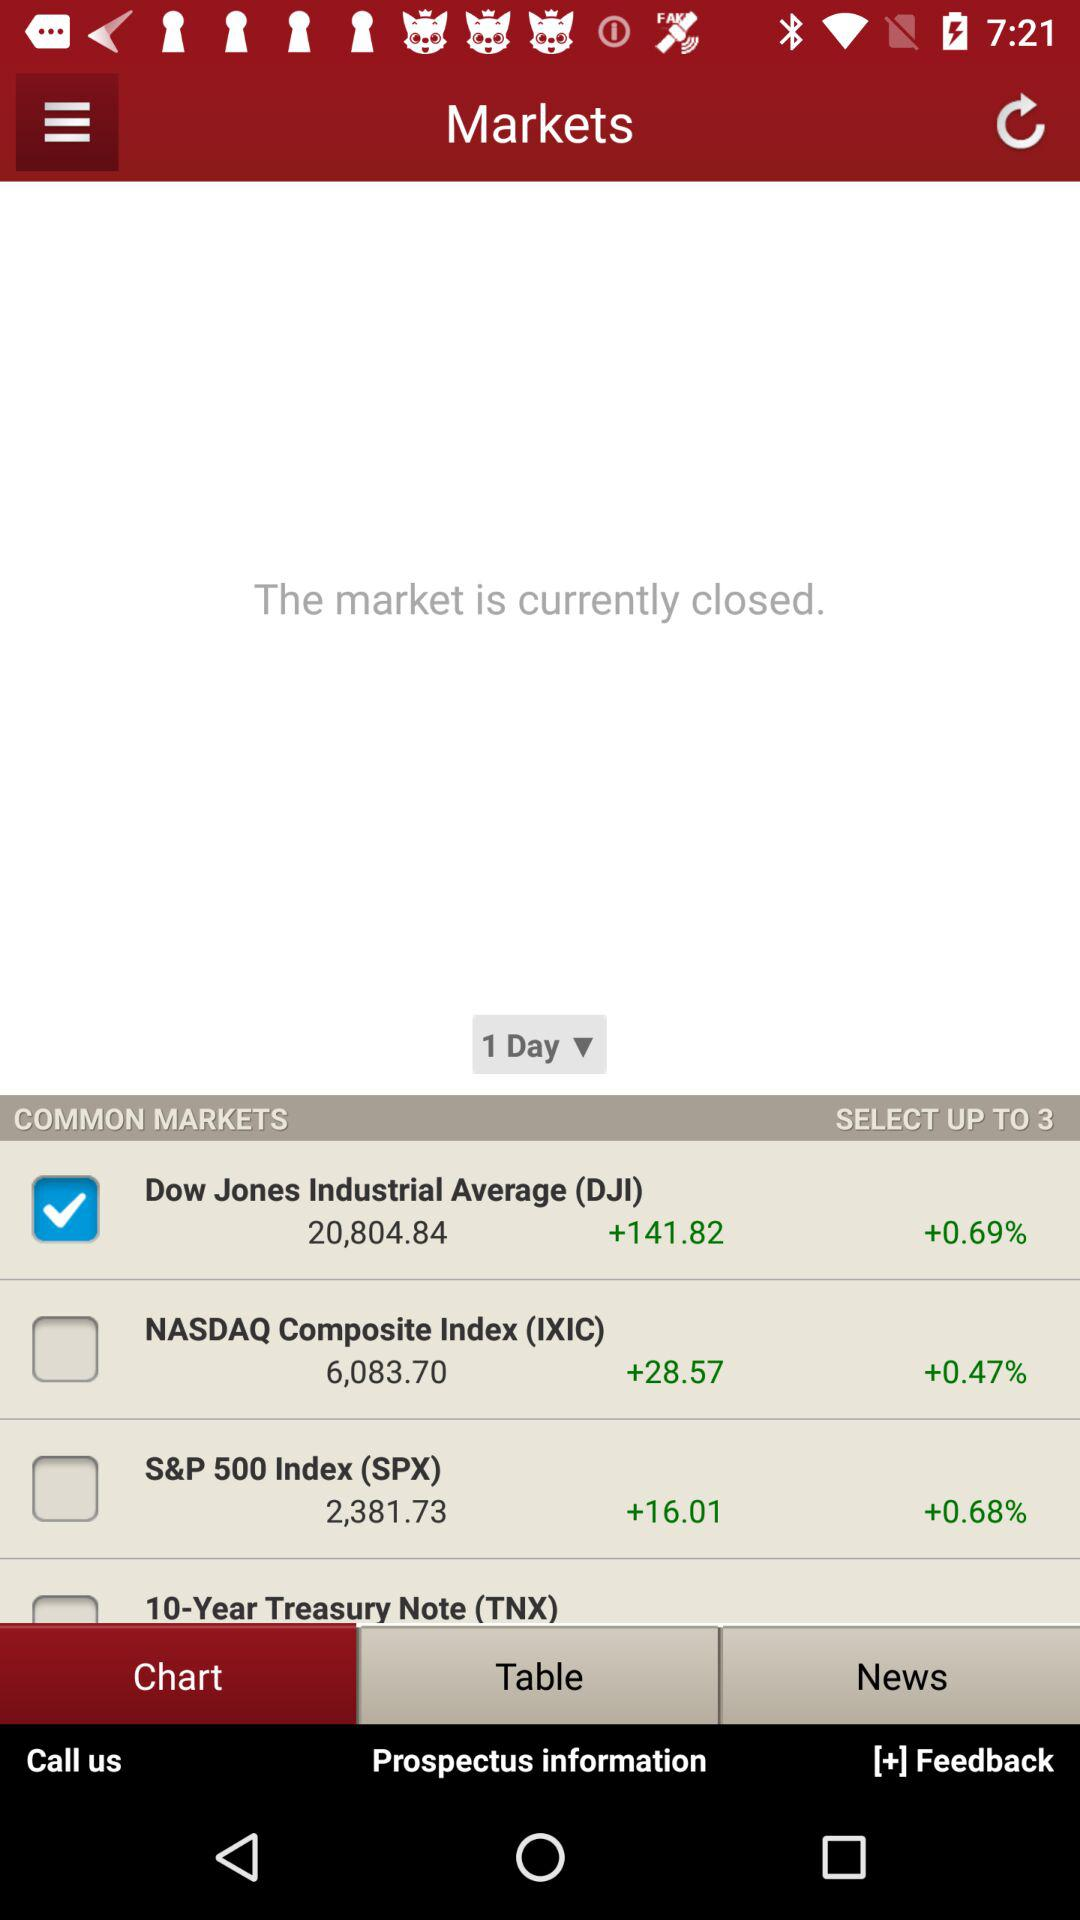By how much is NASDAQ increased? NASDAQ is increased by 28.57. 